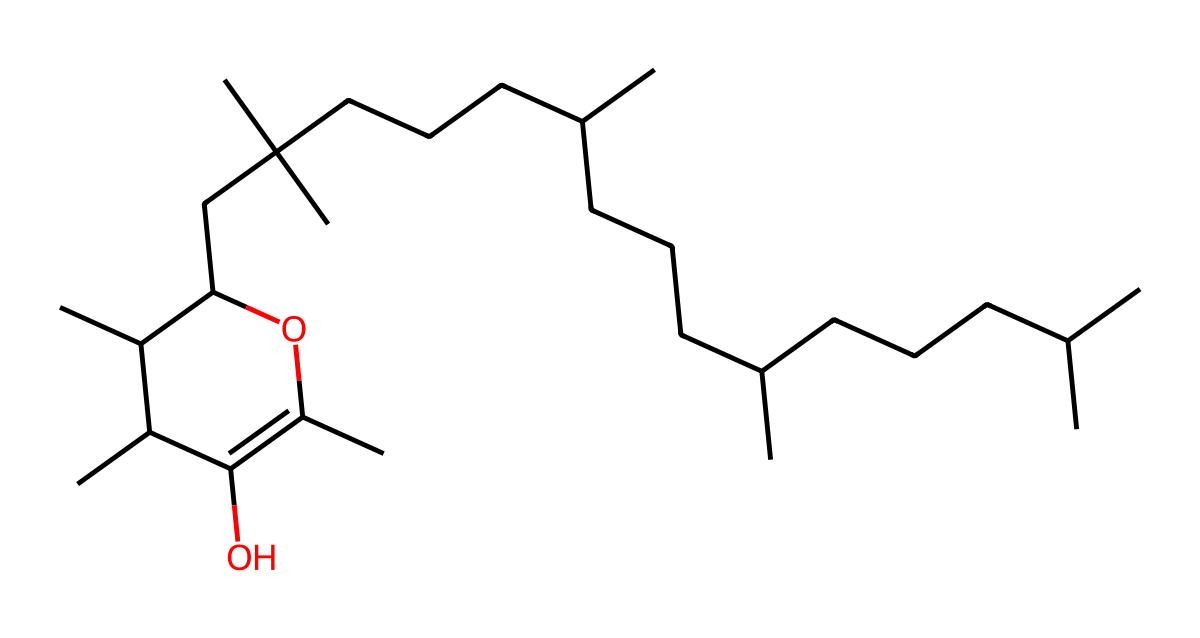How many carbon atoms are present in vitamin E (alpha-tocopherol)? To find the number of carbon atoms, we can analyze the SMILES representation and count the 'C' characters. From the structure, the counting yields a total of 27 carbon atoms.
Answer: 27 What type of functional groups are present in this structure? Upon examining the SMILES, we identify that the structure contains both hydroxyl (-OH) groups, indicated by 'O' in the chemical, which classifies it as an alcohol, as well as multiple aliphatic chains.
Answer: hydroxyl group What is the molecular formula of vitamin E (alpha-tocopherol)? By using the count of each type of atom from the SMILES, we can deduce the molecular formula as C27H50O2, which includes 27 carbon atoms, 50 hydrogen atoms, and 2 oxygen atoms.
Answer: C27H50O2 What does the presence of multiple isoprenoid units suggest about vitamin E's function? The presence of multiple isoprenoid units, indicated by the branched alkyl chains, suggests that vitamin E is involved in lipid-soluble antioxidant activity, typical in vitamins.
Answer: antioxidant activity Is vitamin E (alpha-tocopherol) a polar or non-polar molecule? The presence of the hydroxyl (-OH) group indicates some polarity, but the long hydrocarbon chains dominate, making the overall molecule mostly non-polar.
Answer: non-polar What does the branched nature of the hydrocarbon chain imply for its solubility? The branched hydrocarbon chain structure typically leads to lower packing efficiency compared to linear structures, resulting in reduced intermolecular forces and thus higher lipid solubility.
Answer: higher lipid solubility 